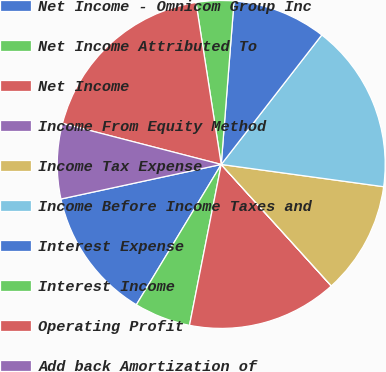Convert chart. <chart><loc_0><loc_0><loc_500><loc_500><pie_chart><fcel>Net Income - Omnicom Group Inc<fcel>Net Income Attributed To<fcel>Net Income<fcel>Income From Equity Method<fcel>Income Tax Expense<fcel>Income Before Income Taxes and<fcel>Interest Expense<fcel>Interest Income<fcel>Operating Profit<fcel>Add back Amortization of<nl><fcel>12.96%<fcel>5.56%<fcel>14.81%<fcel>0.01%<fcel>11.11%<fcel>16.66%<fcel>9.26%<fcel>3.71%<fcel>18.51%<fcel>7.41%<nl></chart> 